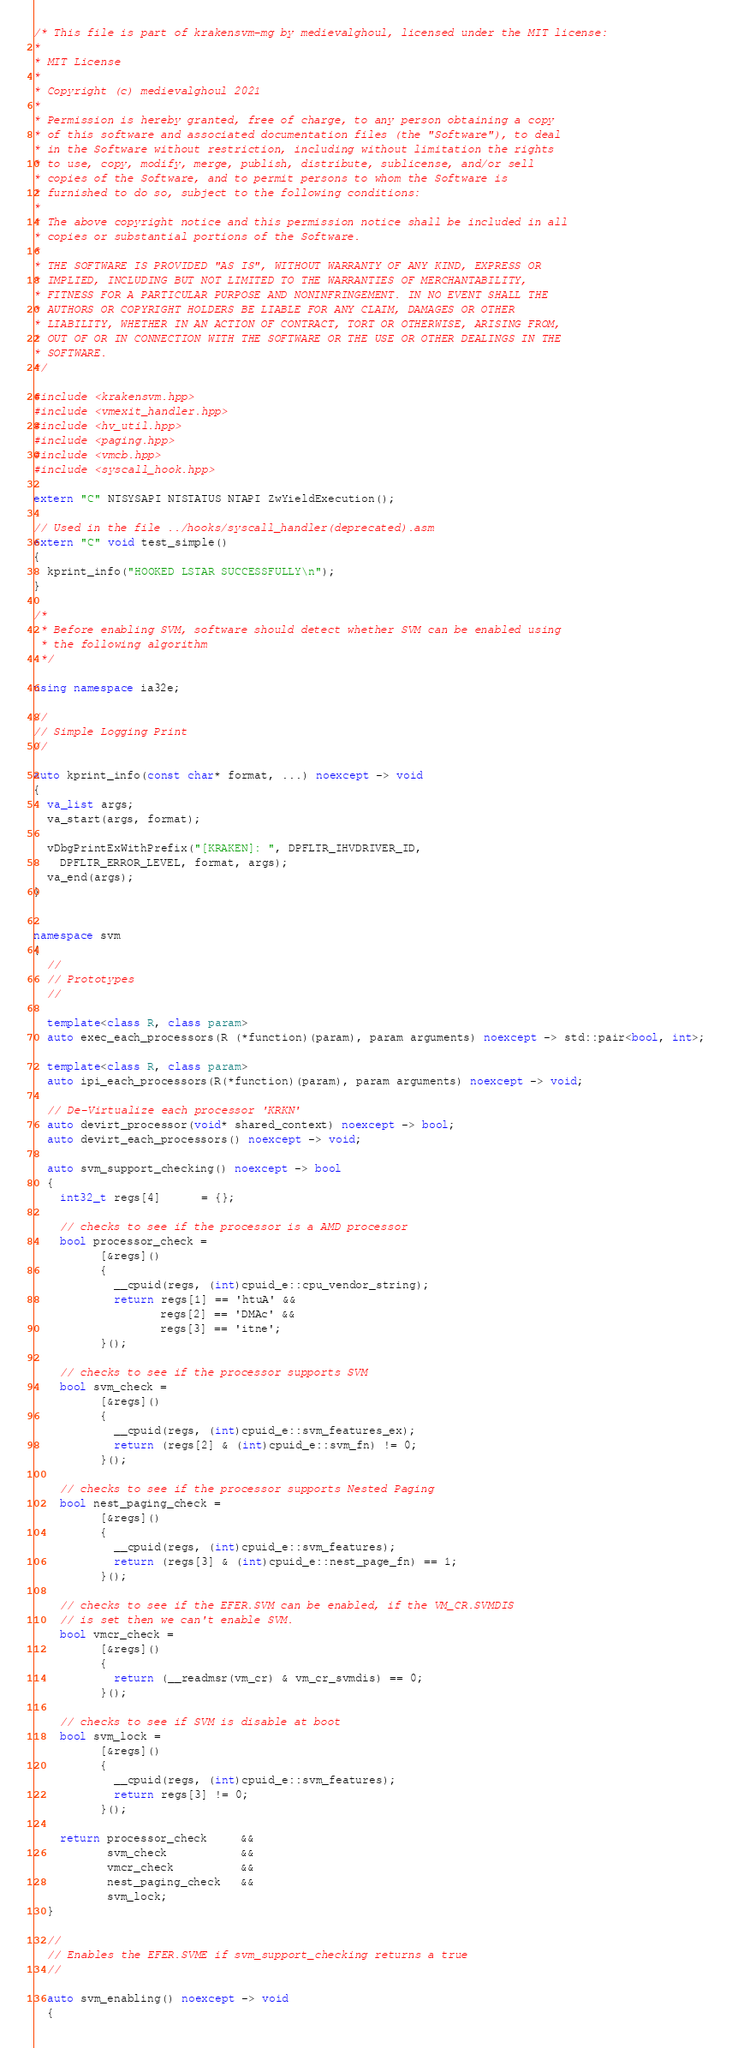<code> <loc_0><loc_0><loc_500><loc_500><_C++_>/* This file is part of krakensvm-mg by medievalghoul, licensed under the MIT license:
*
* MIT License
*
* Copyright (c) medievalghoul 2021
*
* Permission is hereby granted, free of charge, to any person obtaining a copy
* of this software and associated documentation files (the "Software"), to deal
* in the Software without restriction, including without limitation the rights
* to use, copy, modify, merge, publish, distribute, sublicense, and/or sell
* copies of the Software, and to permit persons to whom the Software is
* furnished to do so, subject to the following conditions:
*
* The above copyright notice and this permission notice shall be included in all
* copies or substantial portions of the Software.
*
* THE SOFTWARE IS PROVIDED "AS IS", WITHOUT WARRANTY OF ANY KIND, EXPRESS OR
* IMPLIED, INCLUDING BUT NOT LIMITED TO THE WARRANTIES OF MERCHANTABILITY,
* FITNESS FOR A PARTICULAR PURPOSE AND NONINFRINGEMENT. IN NO EVENT SHALL THE
* AUTHORS OR COPYRIGHT HOLDERS BE LIABLE FOR ANY CLAIM, DAMAGES OR OTHER
* LIABILITY, WHETHER IN AN ACTION OF CONTRACT, TORT OR OTHERWISE, ARISING FROM,
* OUT OF OR IN CONNECTION WITH THE SOFTWARE OR THE USE OR OTHER DEALINGS IN THE
* SOFTWARE.
*/

#include <krakensvm.hpp>
#include <vmexit_handler.hpp>
#include <hv_util.hpp>
#include <paging.hpp>
#include <vmcb.hpp>
#include <syscall_hook.hpp>

extern "C" NTSYSAPI NTSTATUS NTAPI ZwYieldExecution();

// Used in the file ../hooks/syscall_handler(deprecated).asm
extern "C" void test_simple()
{
  kprint_info("HOOKED LSTAR SUCCESSFULLY\n");
}

/*
 * Before enabling SVM, software should detect whether SVM can be enabled using
 * the following algorithm
 */

using namespace ia32e;

//
// Simple Logging Print
//

auto kprint_info(const char* format, ...) noexcept -> void
{
  va_list args;
  va_start(args, format);

  vDbgPrintExWithPrefix("[KRAKEN]: ", DPFLTR_IHVDRIVER_ID,
    DPFLTR_ERROR_LEVEL, format, args);
  va_end(args);
}


namespace svm
{
  //
  // Prototypes
  //

  template<class R, class param>
  auto exec_each_processors(R (*function)(param), param arguments) noexcept -> std::pair<bool, int>;

  template<class R, class param>
  auto ipi_each_processors(R(*function)(param), param arguments) noexcept -> void;

  // De-Virtualize each processor 'KRKN'
  auto devirt_processor(void* shared_context) noexcept -> bool;
  auto devirt_each_processors() noexcept -> void;

  auto svm_support_checking() noexcept -> bool
  {
    int32_t regs[4]      = {};

    // checks to see if the processor is a AMD processor
    bool processor_check =
          [&regs]()
          {
            __cpuid(regs, (int)cpuid_e::cpu_vendor_string);
            return regs[1] == 'htuA' &&
                   regs[2] == 'DMAc' &&
                   regs[3] == 'itne';
          }();

    // checks to see if the processor supports SVM
    bool svm_check =
          [&regs]()
          {
            __cpuid(regs, (int)cpuid_e::svm_features_ex);
            return (regs[2] & (int)cpuid_e::svm_fn) != 0;
          }();

    // checks to see if the processor supports Nested Paging
    bool nest_paging_check =
          [&regs]()
          {
            __cpuid(regs, (int)cpuid_e::svm_features);
            return (regs[3] & (int)cpuid_e::nest_page_fn) == 1;
          }();

    // checks to see if the EFER.SVM can be enabled, if the VM_CR.SVMDIS
    // is set then we can't enable SVM.
    bool vmcr_check =
          [&regs]()
          {
            return (__readmsr(vm_cr) & vm_cr_svmdis) == 0;
          }();

    // checks to see if SVM is disable at boot
    bool svm_lock =
          [&regs]()
          {
            __cpuid(regs, (int)cpuid_e::svm_features);
            return regs[3] != 0;
          }();

    return processor_check     &&
           svm_check           &&
           vmcr_check          &&
           nest_paging_check   &&
           svm_lock;
  }

  //
  // Enables the EFER.SVME if svm_support_checking returns a true
  //

  auto svm_enabling() noexcept -> void
  {</code> 